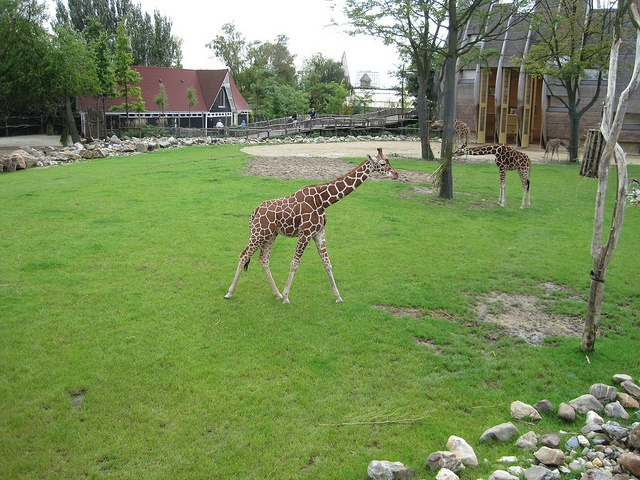Describe the objects in this image and their specific colors. I can see giraffe in green, darkgray, maroon, olive, and gray tones, giraffe in green, gray, black, and darkgray tones, giraffe in green, gray, and darkgray tones, people in green, black, gray, darkgray, and lightgray tones, and people in green, lightgray, darkgray, and gray tones in this image. 